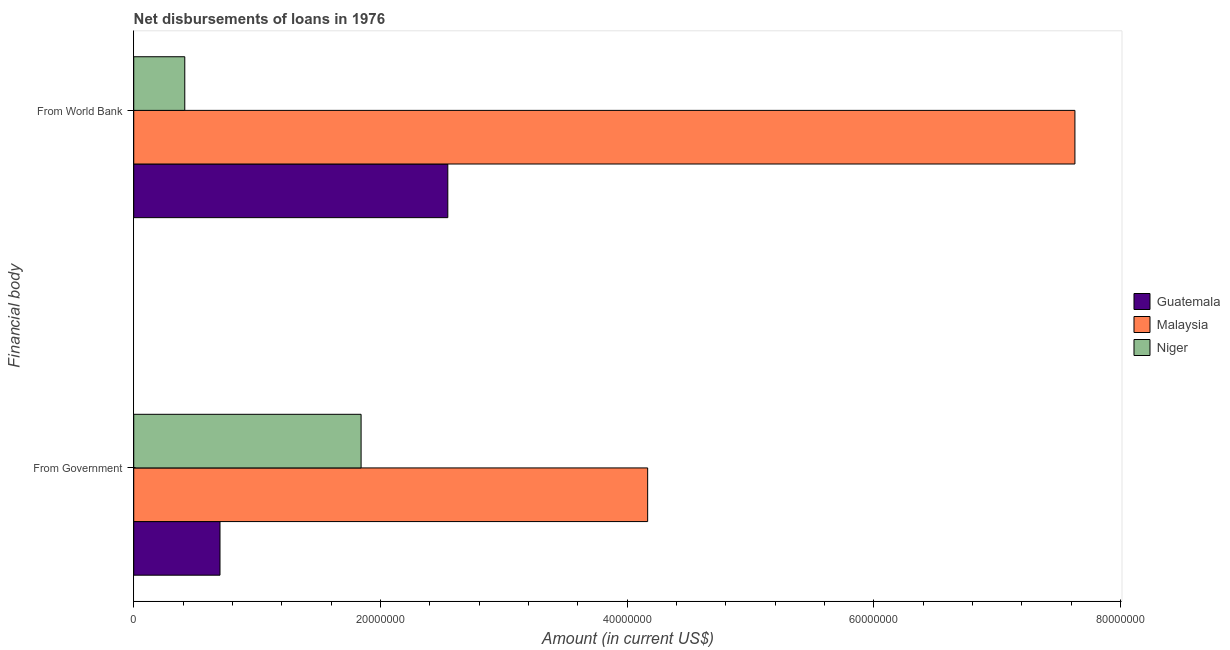How many groups of bars are there?
Ensure brevity in your answer.  2. Are the number of bars per tick equal to the number of legend labels?
Provide a short and direct response. Yes. Are the number of bars on each tick of the Y-axis equal?
Your response must be concise. Yes. How many bars are there on the 1st tick from the top?
Offer a very short reply. 3. How many bars are there on the 2nd tick from the bottom?
Your response must be concise. 3. What is the label of the 2nd group of bars from the top?
Your answer should be very brief. From Government. What is the net disbursements of loan from government in Niger?
Your response must be concise. 1.84e+07. Across all countries, what is the maximum net disbursements of loan from world bank?
Provide a short and direct response. 7.63e+07. Across all countries, what is the minimum net disbursements of loan from world bank?
Offer a very short reply. 4.14e+06. In which country was the net disbursements of loan from world bank maximum?
Offer a terse response. Malaysia. In which country was the net disbursements of loan from government minimum?
Offer a terse response. Guatemala. What is the total net disbursements of loan from world bank in the graph?
Keep it short and to the point. 1.06e+08. What is the difference between the net disbursements of loan from world bank in Guatemala and that in Malaysia?
Give a very brief answer. -5.08e+07. What is the difference between the net disbursements of loan from world bank in Guatemala and the net disbursements of loan from government in Malaysia?
Offer a very short reply. -1.62e+07. What is the average net disbursements of loan from world bank per country?
Make the answer very short. 3.53e+07. What is the difference between the net disbursements of loan from government and net disbursements of loan from world bank in Guatemala?
Make the answer very short. -1.85e+07. What is the ratio of the net disbursements of loan from world bank in Malaysia to that in Guatemala?
Ensure brevity in your answer.  3. In how many countries, is the net disbursements of loan from world bank greater than the average net disbursements of loan from world bank taken over all countries?
Give a very brief answer. 1. What does the 1st bar from the top in From Government represents?
Your answer should be compact. Niger. What does the 3rd bar from the bottom in From World Bank represents?
Offer a terse response. Niger. Are all the bars in the graph horizontal?
Keep it short and to the point. Yes. How many countries are there in the graph?
Your response must be concise. 3. Does the graph contain any zero values?
Provide a succinct answer. No. Does the graph contain grids?
Your answer should be very brief. No. Where does the legend appear in the graph?
Keep it short and to the point. Center right. How many legend labels are there?
Provide a short and direct response. 3. How are the legend labels stacked?
Your answer should be very brief. Vertical. What is the title of the graph?
Provide a succinct answer. Net disbursements of loans in 1976. What is the label or title of the X-axis?
Make the answer very short. Amount (in current US$). What is the label or title of the Y-axis?
Your answer should be compact. Financial body. What is the Amount (in current US$) of Guatemala in From Government?
Provide a succinct answer. 6.99e+06. What is the Amount (in current US$) of Malaysia in From Government?
Ensure brevity in your answer.  4.17e+07. What is the Amount (in current US$) of Niger in From Government?
Provide a succinct answer. 1.84e+07. What is the Amount (in current US$) of Guatemala in From World Bank?
Give a very brief answer. 2.55e+07. What is the Amount (in current US$) in Malaysia in From World Bank?
Offer a very short reply. 7.63e+07. What is the Amount (in current US$) in Niger in From World Bank?
Offer a very short reply. 4.14e+06. Across all Financial body, what is the maximum Amount (in current US$) of Guatemala?
Offer a very short reply. 2.55e+07. Across all Financial body, what is the maximum Amount (in current US$) of Malaysia?
Provide a short and direct response. 7.63e+07. Across all Financial body, what is the maximum Amount (in current US$) in Niger?
Offer a very short reply. 1.84e+07. Across all Financial body, what is the minimum Amount (in current US$) of Guatemala?
Keep it short and to the point. 6.99e+06. Across all Financial body, what is the minimum Amount (in current US$) in Malaysia?
Keep it short and to the point. 4.17e+07. Across all Financial body, what is the minimum Amount (in current US$) of Niger?
Offer a terse response. 4.14e+06. What is the total Amount (in current US$) in Guatemala in the graph?
Keep it short and to the point. 3.25e+07. What is the total Amount (in current US$) of Malaysia in the graph?
Your response must be concise. 1.18e+08. What is the total Amount (in current US$) in Niger in the graph?
Offer a very short reply. 2.26e+07. What is the difference between the Amount (in current US$) in Guatemala in From Government and that in From World Bank?
Offer a terse response. -1.85e+07. What is the difference between the Amount (in current US$) in Malaysia in From Government and that in From World Bank?
Give a very brief answer. -3.46e+07. What is the difference between the Amount (in current US$) of Niger in From Government and that in From World Bank?
Provide a short and direct response. 1.43e+07. What is the difference between the Amount (in current US$) in Guatemala in From Government and the Amount (in current US$) in Malaysia in From World Bank?
Offer a very short reply. -6.93e+07. What is the difference between the Amount (in current US$) of Guatemala in From Government and the Amount (in current US$) of Niger in From World Bank?
Give a very brief answer. 2.86e+06. What is the difference between the Amount (in current US$) of Malaysia in From Government and the Amount (in current US$) of Niger in From World Bank?
Your response must be concise. 3.75e+07. What is the average Amount (in current US$) in Guatemala per Financial body?
Offer a terse response. 1.62e+07. What is the average Amount (in current US$) in Malaysia per Financial body?
Your answer should be very brief. 5.90e+07. What is the average Amount (in current US$) of Niger per Financial body?
Make the answer very short. 1.13e+07. What is the difference between the Amount (in current US$) in Guatemala and Amount (in current US$) in Malaysia in From Government?
Keep it short and to the point. -3.47e+07. What is the difference between the Amount (in current US$) in Guatemala and Amount (in current US$) in Niger in From Government?
Offer a very short reply. -1.14e+07. What is the difference between the Amount (in current US$) of Malaysia and Amount (in current US$) of Niger in From Government?
Keep it short and to the point. 2.32e+07. What is the difference between the Amount (in current US$) in Guatemala and Amount (in current US$) in Malaysia in From World Bank?
Offer a terse response. -5.08e+07. What is the difference between the Amount (in current US$) of Guatemala and Amount (in current US$) of Niger in From World Bank?
Make the answer very short. 2.13e+07. What is the difference between the Amount (in current US$) in Malaysia and Amount (in current US$) in Niger in From World Bank?
Keep it short and to the point. 7.22e+07. What is the ratio of the Amount (in current US$) of Guatemala in From Government to that in From World Bank?
Provide a succinct answer. 0.27. What is the ratio of the Amount (in current US$) of Malaysia in From Government to that in From World Bank?
Your response must be concise. 0.55. What is the ratio of the Amount (in current US$) of Niger in From Government to that in From World Bank?
Make the answer very short. 4.45. What is the difference between the highest and the second highest Amount (in current US$) in Guatemala?
Give a very brief answer. 1.85e+07. What is the difference between the highest and the second highest Amount (in current US$) of Malaysia?
Your response must be concise. 3.46e+07. What is the difference between the highest and the second highest Amount (in current US$) of Niger?
Your answer should be compact. 1.43e+07. What is the difference between the highest and the lowest Amount (in current US$) in Guatemala?
Offer a terse response. 1.85e+07. What is the difference between the highest and the lowest Amount (in current US$) of Malaysia?
Make the answer very short. 3.46e+07. What is the difference between the highest and the lowest Amount (in current US$) in Niger?
Offer a very short reply. 1.43e+07. 